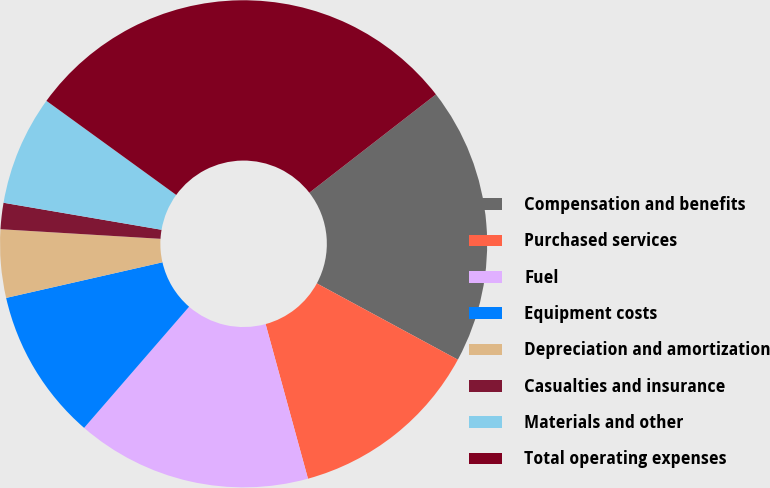Convert chart. <chart><loc_0><loc_0><loc_500><loc_500><pie_chart><fcel>Compensation and benefits<fcel>Purchased services<fcel>Fuel<fcel>Equipment costs<fcel>Depreciation and amortization<fcel>Casualties and insurance<fcel>Materials and other<fcel>Total operating expenses<nl><fcel>18.4%<fcel>12.85%<fcel>15.62%<fcel>10.07%<fcel>4.52%<fcel>1.74%<fcel>7.29%<fcel>29.5%<nl></chart> 